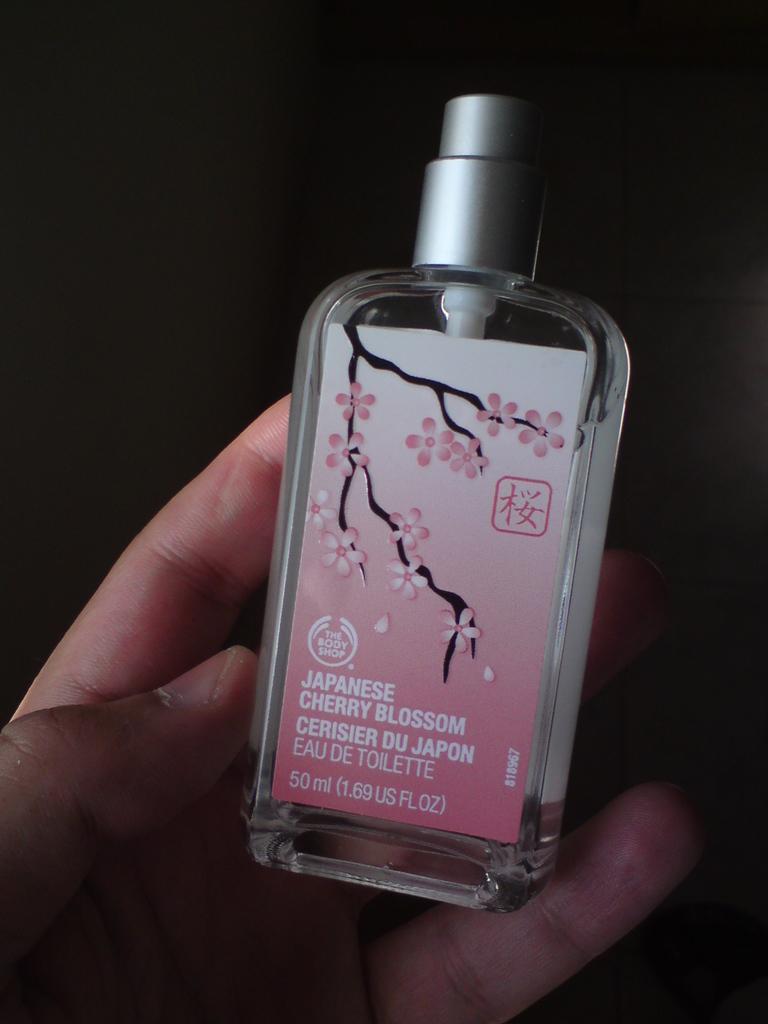What is the perfume scent?
Your answer should be compact. Japanese cherry blossom. How many milliliters are in this bottle?
Provide a succinct answer. 50. 